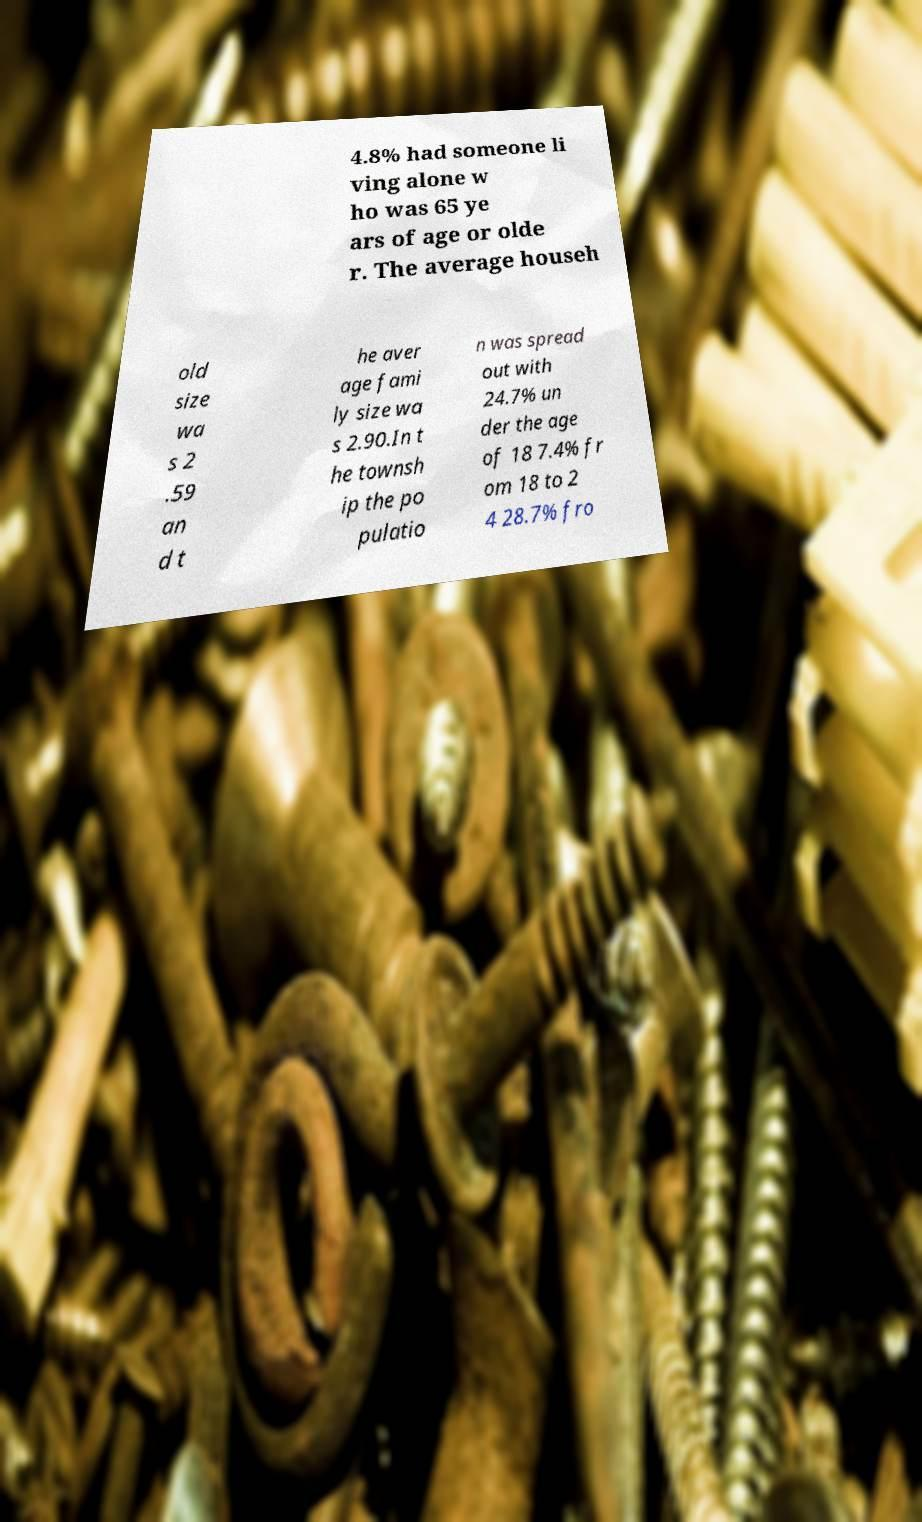Please identify and transcribe the text found in this image. 4.8% had someone li ving alone w ho was 65 ye ars of age or olde r. The average househ old size wa s 2 .59 an d t he aver age fami ly size wa s 2.90.In t he townsh ip the po pulatio n was spread out with 24.7% un der the age of 18 7.4% fr om 18 to 2 4 28.7% fro 